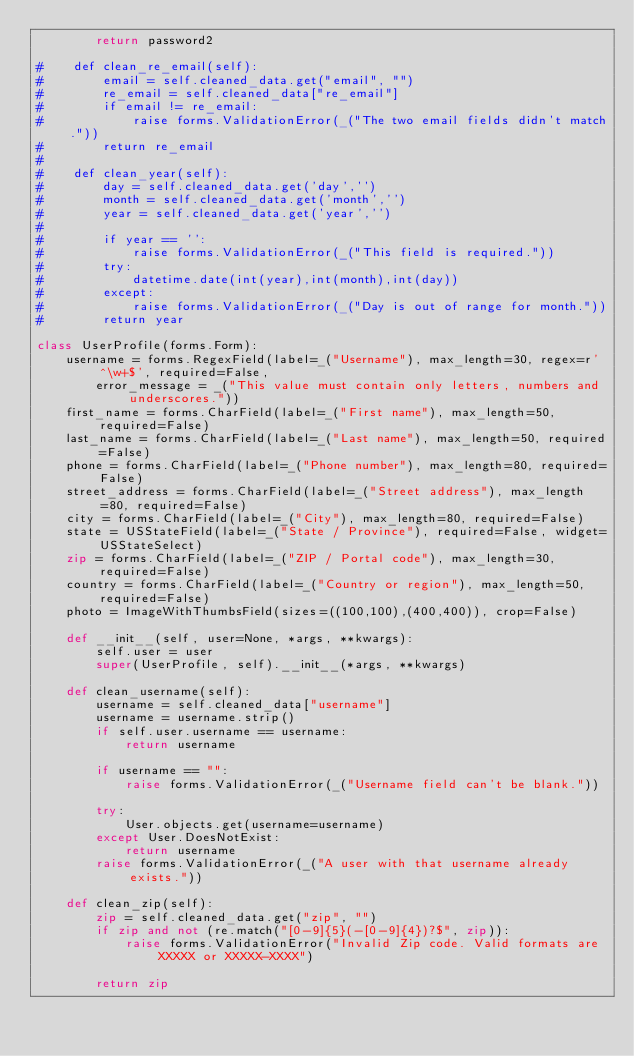Convert code to text. <code><loc_0><loc_0><loc_500><loc_500><_Python_>        return password2

#    def clean_re_email(self):
#        email = self.cleaned_data.get("email", "")
#        re_email = self.cleaned_data["re_email"]
#        if email != re_email:
#            raise forms.ValidationError(_("The two email fields didn't match."))
#        return re_email
#
#    def clean_year(self):
#        day = self.cleaned_data.get('day','')
#        month = self.cleaned_data.get('month','')
#        year = self.cleaned_data.get('year','')
#        
#        if year == '':
#            raise forms.ValidationError(_("This field is required."))
#        try:
#            datetime.date(int(year),int(month),int(day))
#        except:
#            raise forms.ValidationError(_("Day is out of range for month."))
#        return year

class UserProfile(forms.Form):
    username = forms.RegexField(label=_("Username"), max_length=30, regex=r'^\w+$', required=False,
        error_message = _("This value must contain only letters, numbers and underscores."))
    first_name = forms.CharField(label=_("First name"), max_length=50, required=False) 
    last_name = forms.CharField(label=_("Last name"), max_length=50, required=False)
    phone = forms.CharField(label=_("Phone number"), max_length=80, required=False)
    street_address = forms.CharField(label=_("Street address"), max_length=80, required=False)
    city = forms.CharField(label=_("City"), max_length=80, required=False)
    state = USStateField(label=_("State / Province"), required=False, widget=USStateSelect)
    zip = forms.CharField(label=_("ZIP / Portal code"), max_length=30, required=False)
    country = forms.CharField(label=_("Country or region"), max_length=50, required=False)
    photo = ImageWithThumbsField(sizes=((100,100),(400,400)), crop=False)

    def __init__(self, user=None, *args, **kwargs):
        self.user = user
        super(UserProfile, self).__init__(*args, **kwargs)

    def clean_username(self):
        username = self.cleaned_data["username"]
        username = username.strip()
        if self.user.username == username:
            return username
        
        if username == "":
            raise forms.ValidationError(_("Username field can't be blank."))
        
        try:
            User.objects.get(username=username)
        except User.DoesNotExist:
            return username
        raise forms.ValidationError(_("A user with that username already exists."))

    def clean_zip(self):
        zip = self.cleaned_data.get("zip", "")
        if zip and not (re.match("[0-9]{5}(-[0-9]{4})?$", zip)):
            raise forms.ValidationError("Invalid Zip code. Valid formats are XXXXX or XXXXX-XXXX")
           
        return zip

</code> 